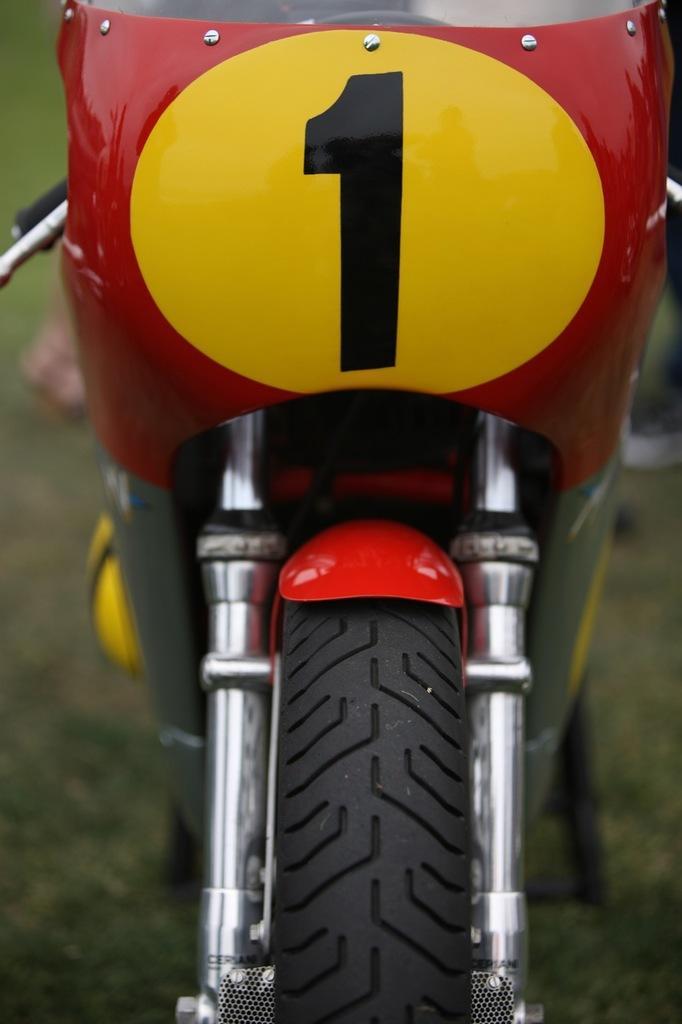Could you give a brief overview of what you see in this image? In this image we can see front part of a motorcycle which is in red and yellow color. 